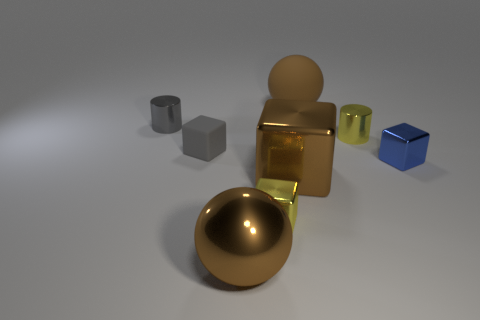Subtract all small yellow cubes. How many cubes are left? 3 Subtract all yellow cubes. Subtract all red cylinders. How many cubes are left? 3 Subtract all green blocks. How many brown cylinders are left? 0 Add 5 cylinders. How many cylinders exist? 7 Add 1 small yellow cubes. How many objects exist? 9 Subtract all gray cubes. How many cubes are left? 3 Subtract 1 gray cylinders. How many objects are left? 7 Subtract all spheres. How many objects are left? 6 Subtract 2 blocks. How many blocks are left? 2 Subtract all tiny yellow things. Subtract all tiny shiny cylinders. How many objects are left? 4 